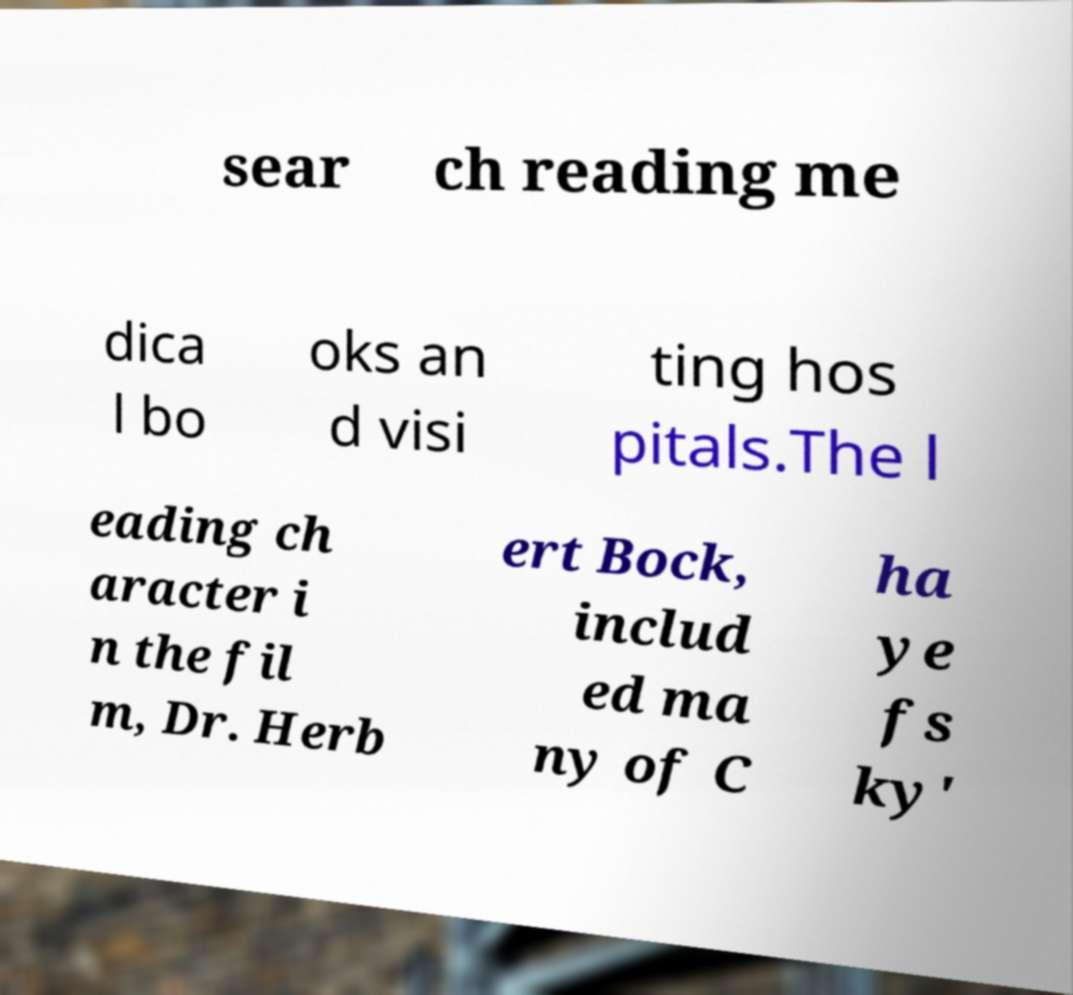Can you read and provide the text displayed in the image?This photo seems to have some interesting text. Can you extract and type it out for me? sear ch reading me dica l bo oks an d visi ting hos pitals.The l eading ch aracter i n the fil m, Dr. Herb ert Bock, includ ed ma ny of C ha ye fs ky' 